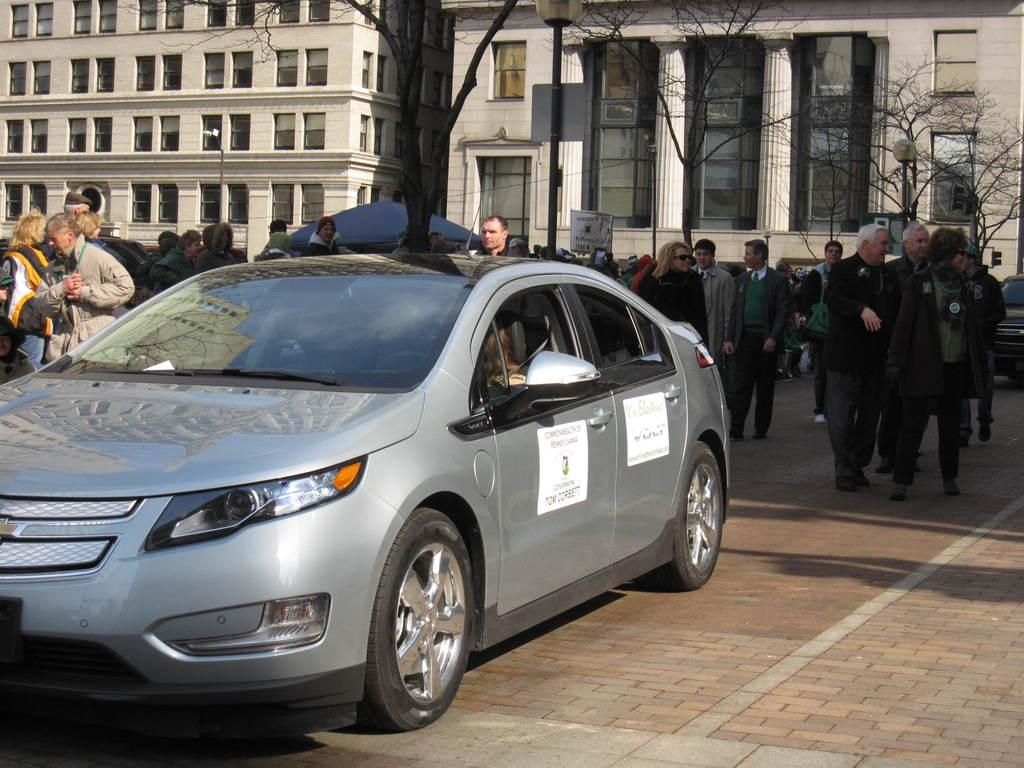What is the main subject of the picture? The main subject of the picture is a car. What are the people in the picture doing? The people are standing beside and behind the car. What can be seen in the background of the picture? There are trees and buildings in the background of the picture. What is the price of the cattle in the image? There are no cattle present in the image, so it is not possible to determine their price. 